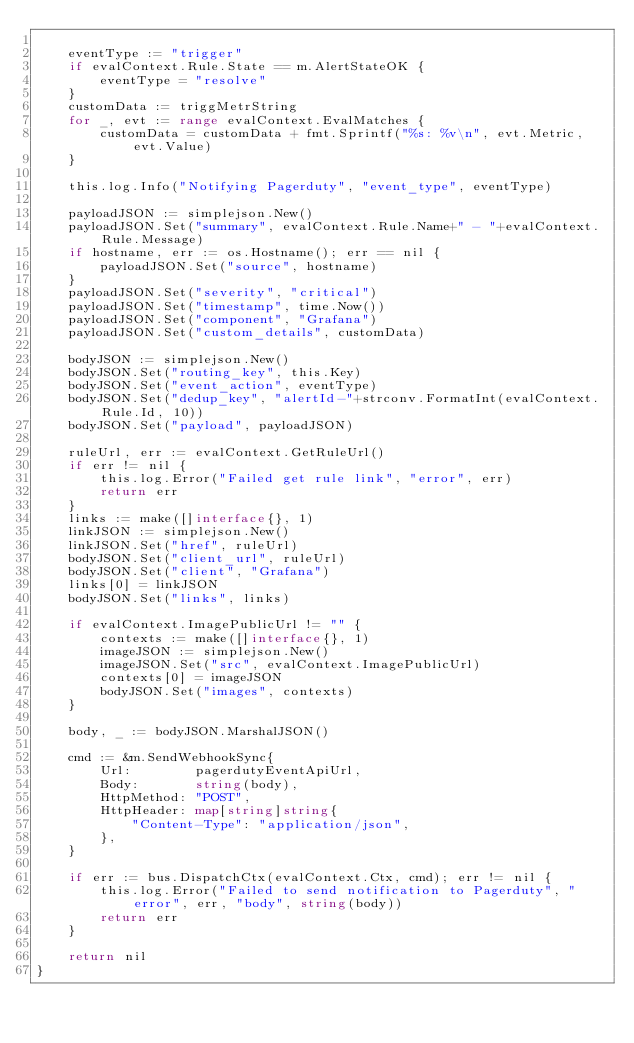<code> <loc_0><loc_0><loc_500><loc_500><_Go_>
	eventType := "trigger"
	if evalContext.Rule.State == m.AlertStateOK {
		eventType = "resolve"
	}
	customData := triggMetrString
	for _, evt := range evalContext.EvalMatches {
		customData = customData + fmt.Sprintf("%s: %v\n", evt.Metric, evt.Value)
	}

	this.log.Info("Notifying Pagerduty", "event_type", eventType)

	payloadJSON := simplejson.New()
	payloadJSON.Set("summary", evalContext.Rule.Name+" - "+evalContext.Rule.Message)
	if hostname, err := os.Hostname(); err == nil {
		payloadJSON.Set("source", hostname)
	}
	payloadJSON.Set("severity", "critical")
	payloadJSON.Set("timestamp", time.Now())
	payloadJSON.Set("component", "Grafana")
	payloadJSON.Set("custom_details", customData)

	bodyJSON := simplejson.New()
	bodyJSON.Set("routing_key", this.Key)
	bodyJSON.Set("event_action", eventType)
	bodyJSON.Set("dedup_key", "alertId-"+strconv.FormatInt(evalContext.Rule.Id, 10))
	bodyJSON.Set("payload", payloadJSON)

	ruleUrl, err := evalContext.GetRuleUrl()
	if err != nil {
		this.log.Error("Failed get rule link", "error", err)
		return err
	}
	links := make([]interface{}, 1)
	linkJSON := simplejson.New()
	linkJSON.Set("href", ruleUrl)
	bodyJSON.Set("client_url", ruleUrl)
	bodyJSON.Set("client", "Grafana")
	links[0] = linkJSON
	bodyJSON.Set("links", links)

	if evalContext.ImagePublicUrl != "" {
		contexts := make([]interface{}, 1)
		imageJSON := simplejson.New()
		imageJSON.Set("src", evalContext.ImagePublicUrl)
		contexts[0] = imageJSON
		bodyJSON.Set("images", contexts)
	}

	body, _ := bodyJSON.MarshalJSON()

	cmd := &m.SendWebhookSync{
		Url:        pagerdutyEventApiUrl,
		Body:       string(body),
		HttpMethod: "POST",
		HttpHeader: map[string]string{
			"Content-Type": "application/json",
		},
	}

	if err := bus.DispatchCtx(evalContext.Ctx, cmd); err != nil {
		this.log.Error("Failed to send notification to Pagerduty", "error", err, "body", string(body))
		return err
	}

	return nil
}
</code> 